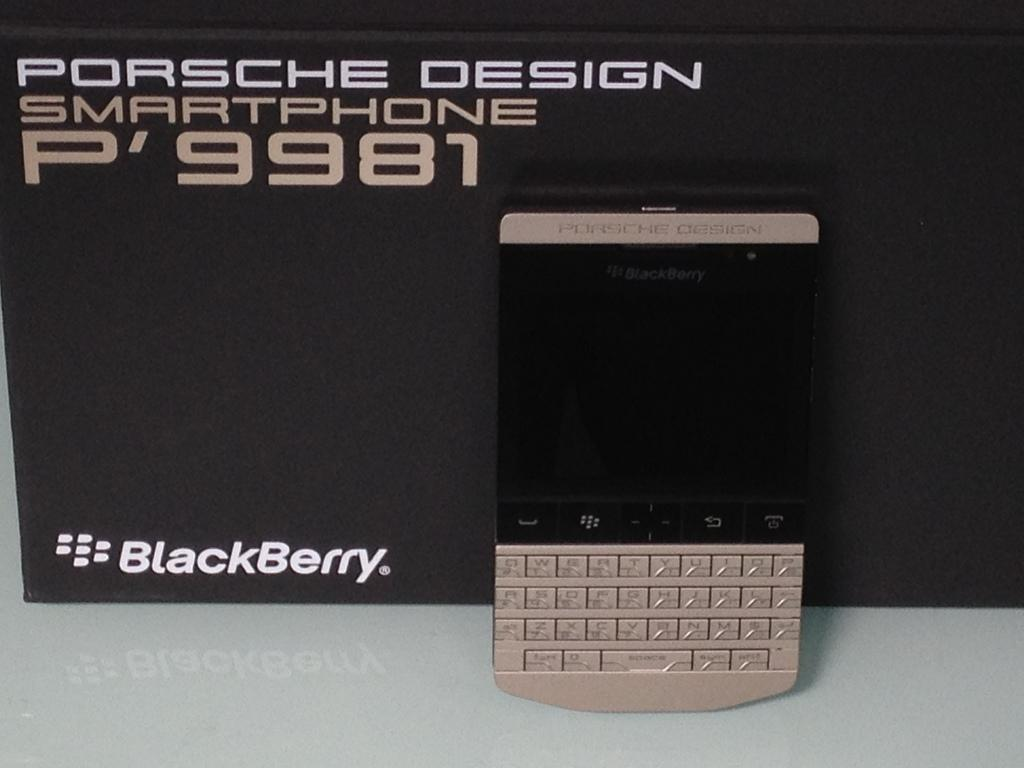<image>
Share a concise interpretation of the image provided. A Blackberry device Porsche Design standing against a black background. 